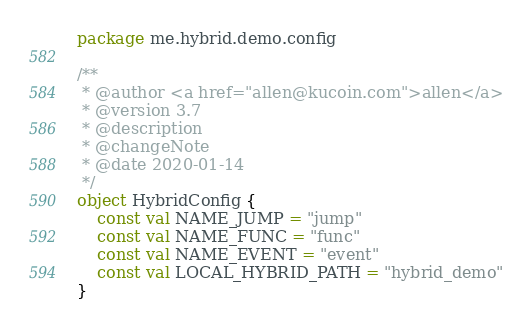Convert code to text. <code><loc_0><loc_0><loc_500><loc_500><_Kotlin_>package me.hybrid.demo.config

/**
 * @author <a href="allen@kucoin.com">allen</a>
 * @version 3.7
 * @description
 * @changeNote
 * @date 2020-01-14
 */
object HybridConfig {
    const val NAME_JUMP = "jump"
    const val NAME_FUNC = "func"
    const val NAME_EVENT = "event"
    const val LOCAL_HYBRID_PATH = "hybrid_demo"
}</code> 